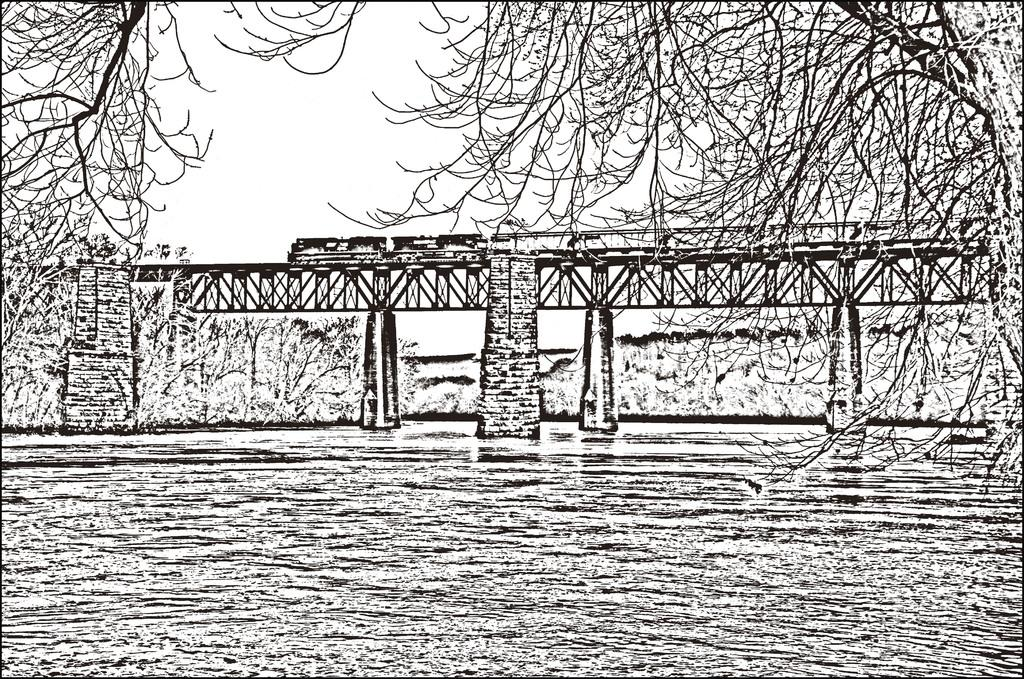What is the color scheme of the image? The image is black and white. What structure can be seen in the image? There is a railway bridge in the image. What is happening on the bridge? A train is moving on the bridge. What type of vegetation is present in the image? There are many trees in the image. What is the reaction of the trees to the train passing by? There is no indication of the trees reacting to the train in the image, as trees do not have the ability to react in the same way as living beings. 